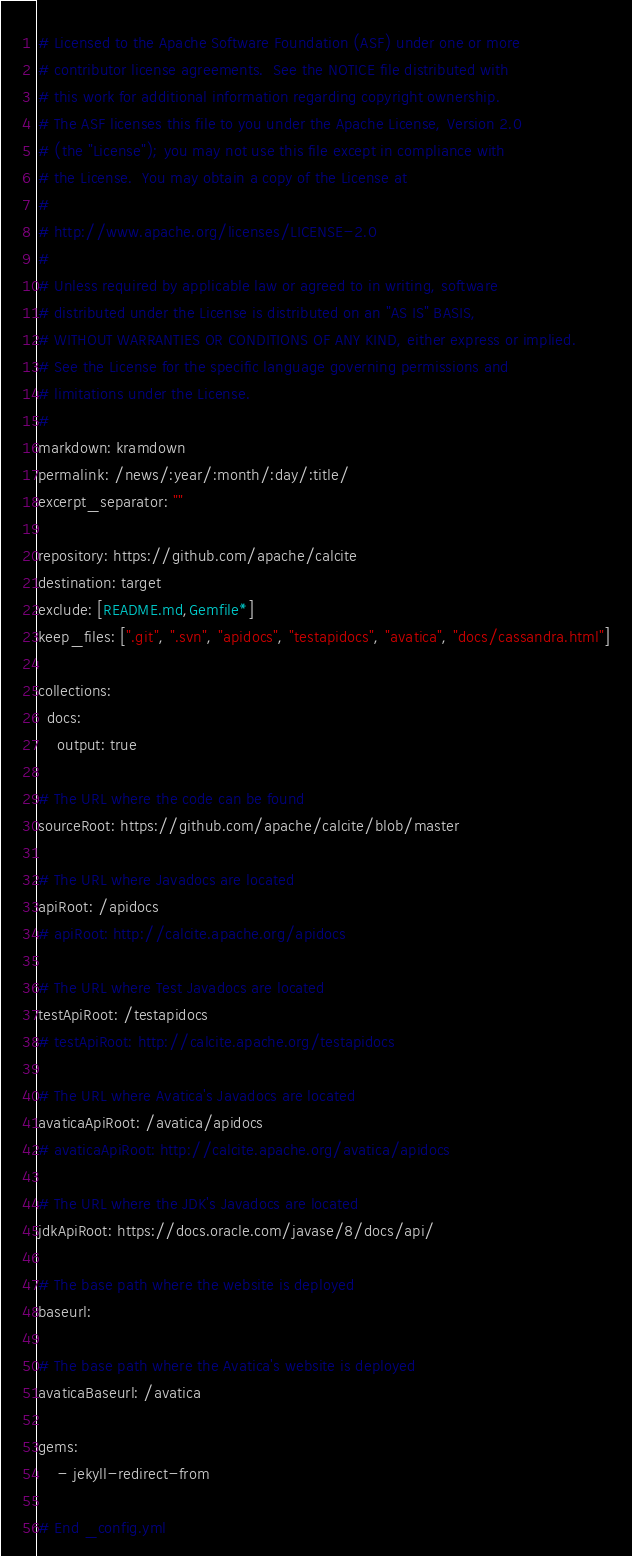Convert code to text. <code><loc_0><loc_0><loc_500><loc_500><_YAML_># Licensed to the Apache Software Foundation (ASF) under one or more
# contributor license agreements.  See the NOTICE file distributed with
# this work for additional information regarding copyright ownership.
# The ASF licenses this file to you under the Apache License, Version 2.0
# (the "License"); you may not use this file except in compliance with
# the License.  You may obtain a copy of the License at
#
# http://www.apache.org/licenses/LICENSE-2.0
#
# Unless required by applicable law or agreed to in writing, software
# distributed under the License is distributed on an "AS IS" BASIS,
# WITHOUT WARRANTIES OR CONDITIONS OF ANY KIND, either express or implied.
# See the License for the specific language governing permissions and
# limitations under the License.
#
markdown: kramdown
permalink: /news/:year/:month/:day/:title/
excerpt_separator: ""

repository: https://github.com/apache/calcite
destination: target
exclude: [README.md,Gemfile*]
keep_files: [".git", ".svn", "apidocs", "testapidocs", "avatica", "docs/cassandra.html"]

collections:
  docs:
    output: true

# The URL where the code can be found
sourceRoot: https://github.com/apache/calcite/blob/master

# The URL where Javadocs are located
apiRoot: /apidocs
# apiRoot: http://calcite.apache.org/apidocs

# The URL where Test Javadocs are located
testApiRoot: /testapidocs
# testApiRoot: http://calcite.apache.org/testapidocs

# The URL where Avatica's Javadocs are located
avaticaApiRoot: /avatica/apidocs
# avaticaApiRoot: http://calcite.apache.org/avatica/apidocs

# The URL where the JDK's Javadocs are located
jdkApiRoot: https://docs.oracle.com/javase/8/docs/api/

# The base path where the website is deployed
baseurl:

# The base path where the Avatica's website is deployed
avaticaBaseurl: /avatica

gems:
    - jekyll-redirect-from

# End _config.yml
</code> 